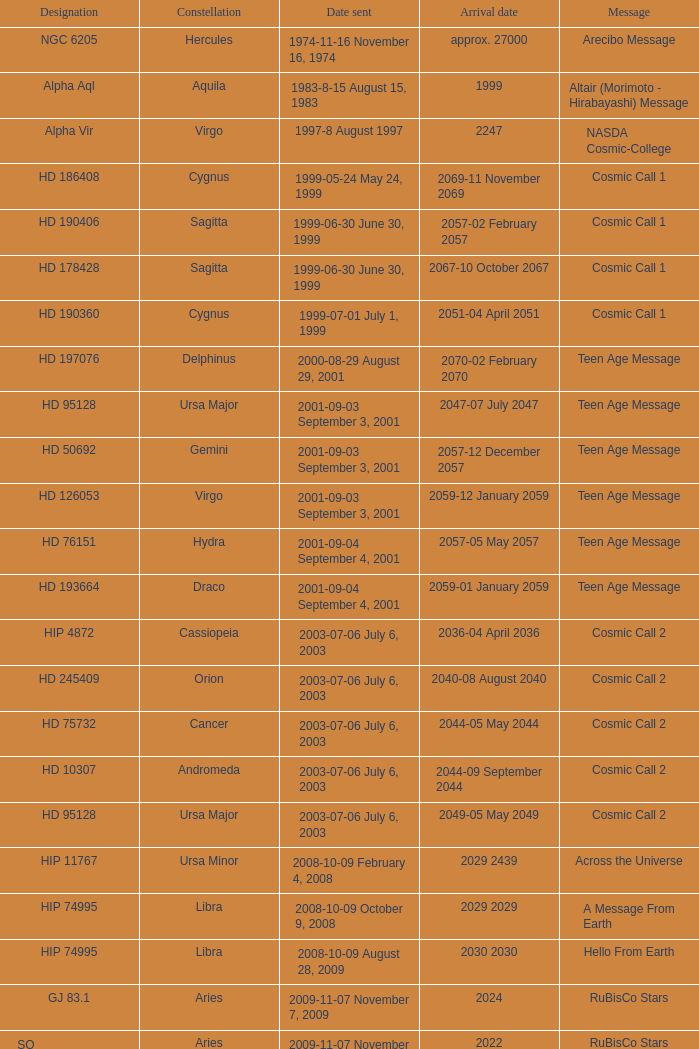What is the location of hip 4872? Cassiopeia. 